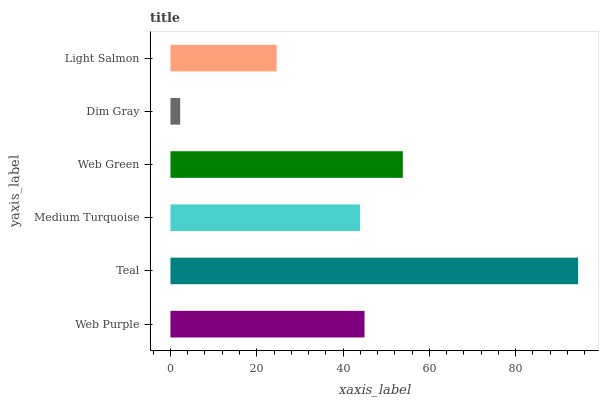Is Dim Gray the minimum?
Answer yes or no. Yes. Is Teal the maximum?
Answer yes or no. Yes. Is Medium Turquoise the minimum?
Answer yes or no. No. Is Medium Turquoise the maximum?
Answer yes or no. No. Is Teal greater than Medium Turquoise?
Answer yes or no. Yes. Is Medium Turquoise less than Teal?
Answer yes or no. Yes. Is Medium Turquoise greater than Teal?
Answer yes or no. No. Is Teal less than Medium Turquoise?
Answer yes or no. No. Is Web Purple the high median?
Answer yes or no. Yes. Is Medium Turquoise the low median?
Answer yes or no. Yes. Is Dim Gray the high median?
Answer yes or no. No. Is Dim Gray the low median?
Answer yes or no. No. 